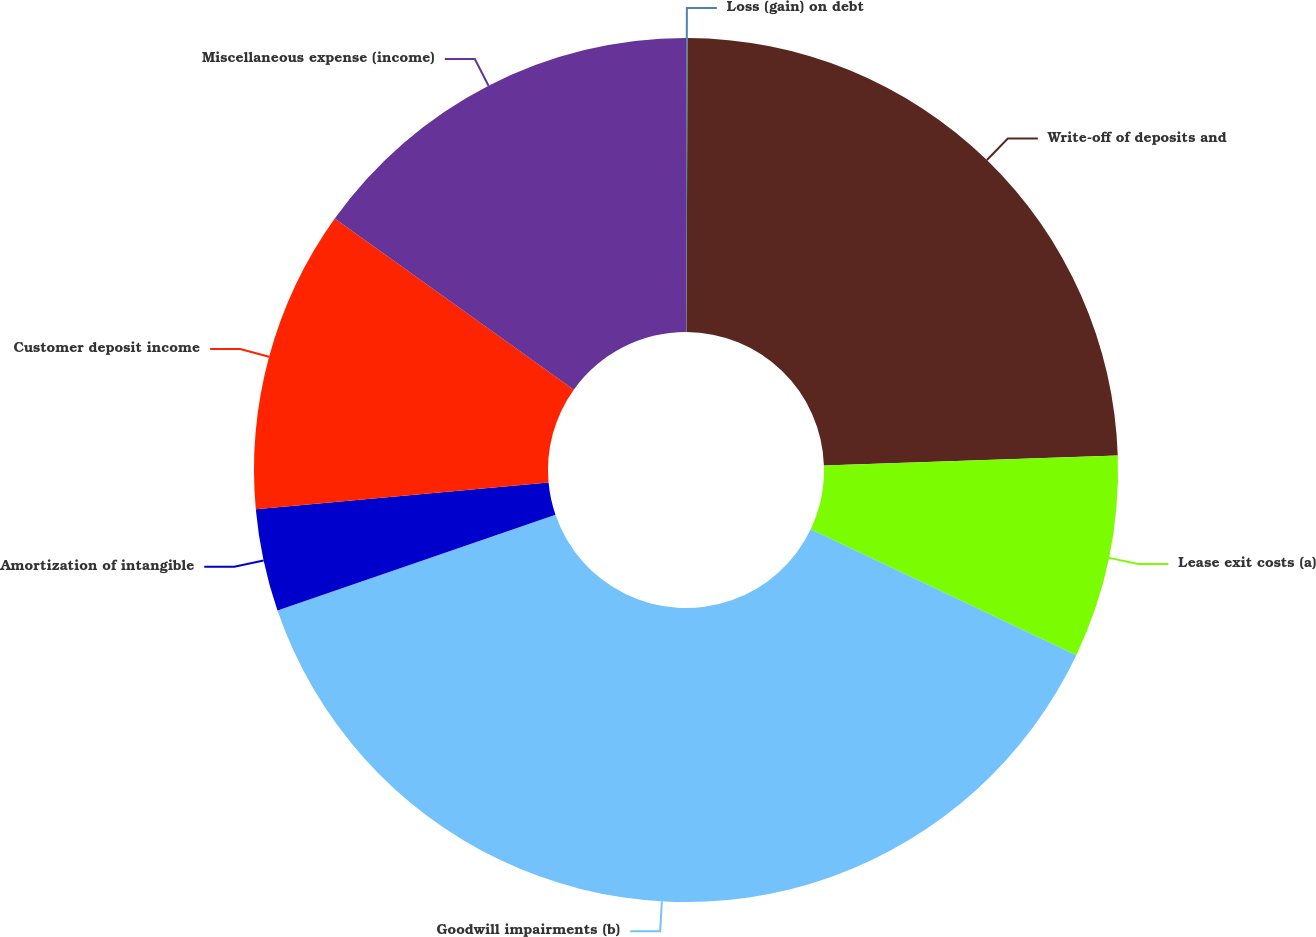<chart> <loc_0><loc_0><loc_500><loc_500><pie_chart><fcel>Loss (gain) on debt<fcel>Write-off of deposits and<fcel>Lease exit costs (a)<fcel>Goodwill impairments (b)<fcel>Amortization of intangible<fcel>Customer deposit income<fcel>Miscellaneous expense (income)<nl><fcel>0.06%<fcel>24.41%<fcel>7.58%<fcel>37.68%<fcel>3.82%<fcel>11.34%<fcel>15.11%<nl></chart> 